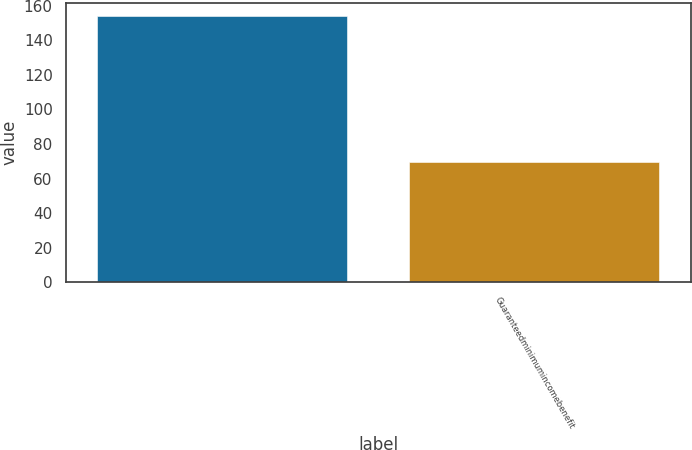<chart> <loc_0><loc_0><loc_500><loc_500><bar_chart><ecel><fcel>Guaranteedminimumincomebenefit<nl><fcel>154<fcel>69.4<nl></chart> 